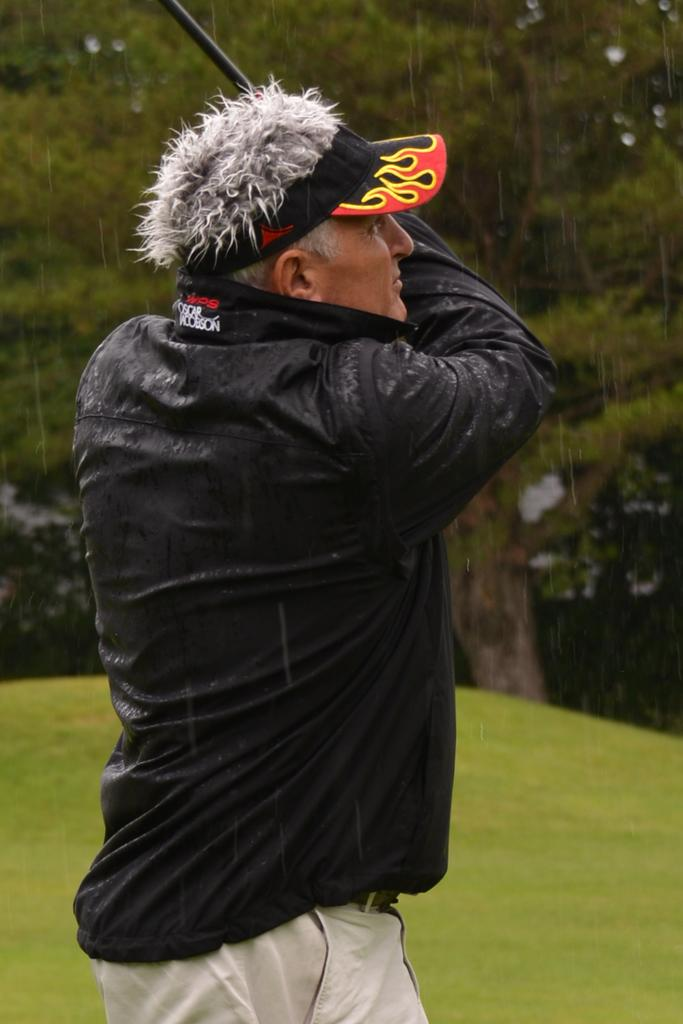What is the main subject of the image? There is a man standing in the center of the image. What is the man holding in the image? The man is holding a black stick. What type of surface is under the man's feet? There is grass on the ground in the center of the image. What can be seen in the background of the image? There is a tree in the background of the image. What type of bean is growing on the tree in the background? There are no beans visible in the image, and the tree in the background does not have any beans growing on it. 